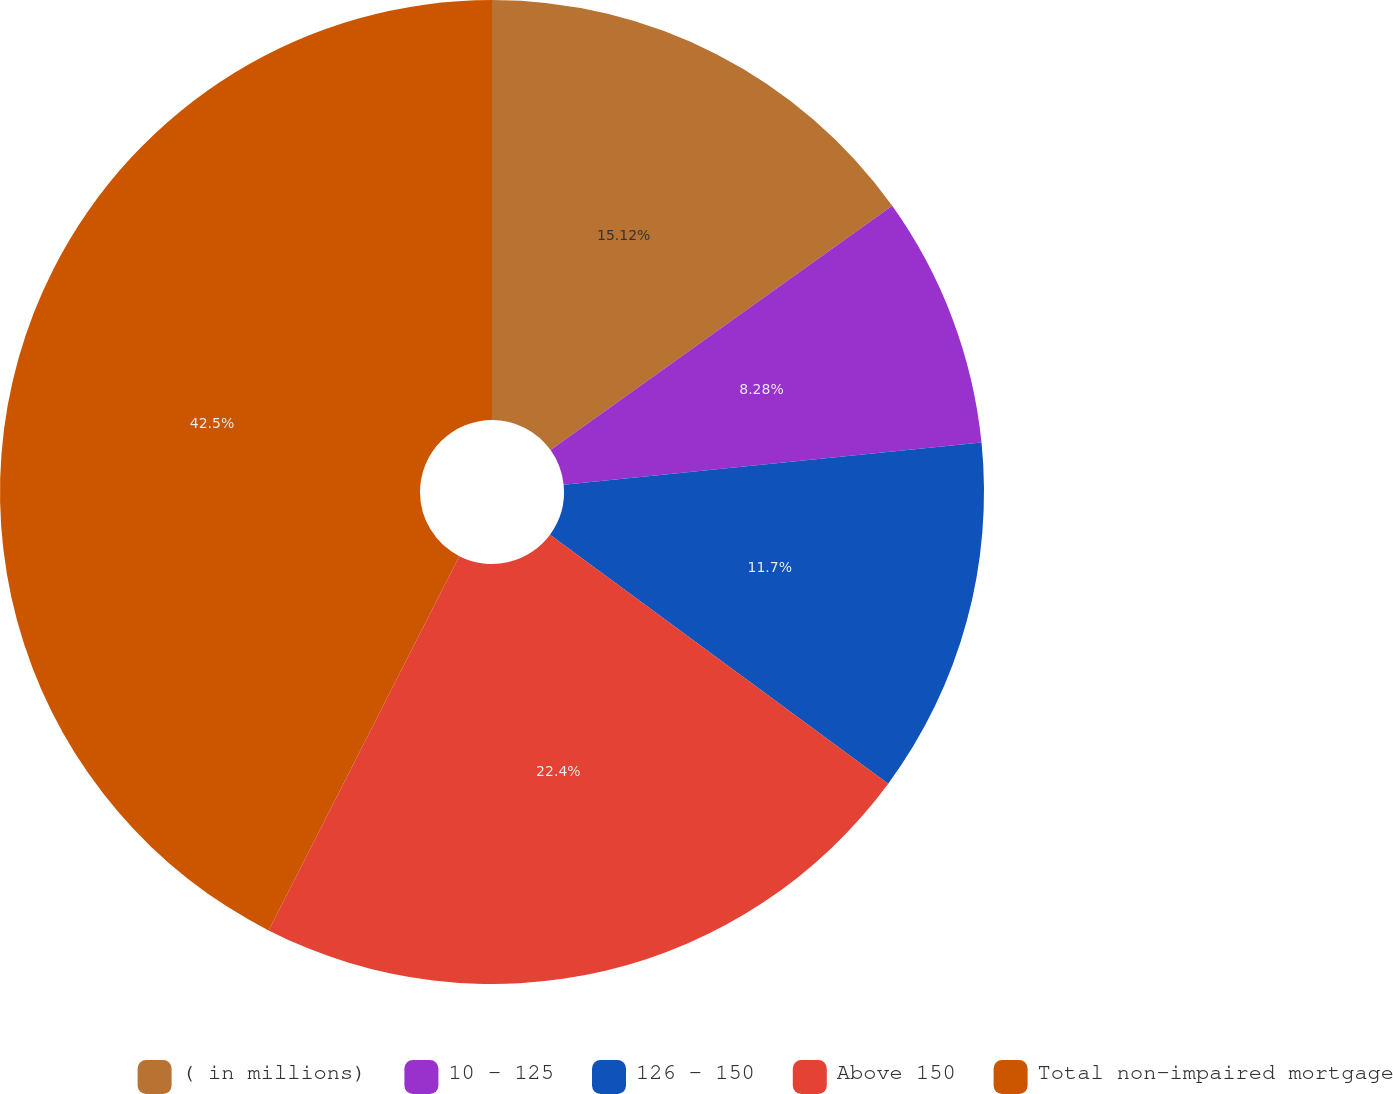Convert chart. <chart><loc_0><loc_0><loc_500><loc_500><pie_chart><fcel>( in millions)<fcel>10 - 125<fcel>126 - 150<fcel>Above 150<fcel>Total non-impaired mortgage<nl><fcel>15.12%<fcel>8.28%<fcel>11.7%<fcel>22.4%<fcel>42.5%<nl></chart> 